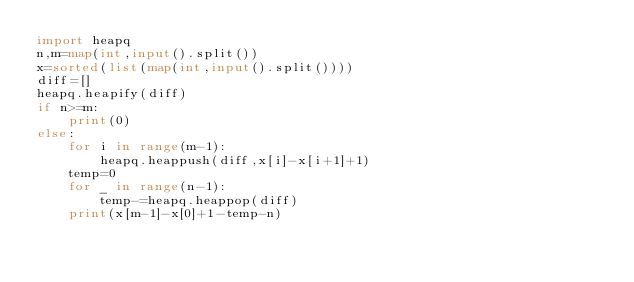Convert code to text. <code><loc_0><loc_0><loc_500><loc_500><_Python_>import heapq
n,m=map(int,input().split())
x=sorted(list(map(int,input().split())))
diff=[]
heapq.heapify(diff)
if n>=m:
    print(0)
else:
    for i in range(m-1):
        heapq.heappush(diff,x[i]-x[i+1]+1)
    temp=0
    for _ in range(n-1):
        temp-=heapq.heappop(diff)
    print(x[m-1]-x[0]+1-temp-n)</code> 